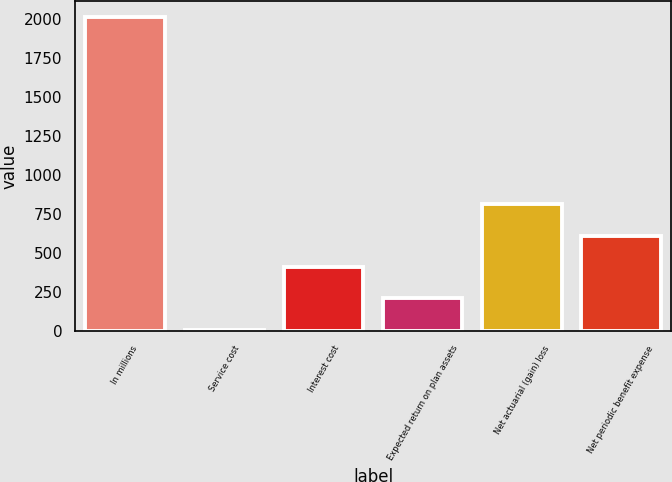Convert chart. <chart><loc_0><loc_0><loc_500><loc_500><bar_chart><fcel>In millions<fcel>Service cost<fcel>Interest cost<fcel>Expected return on plan assets<fcel>Net actuarial (gain) loss<fcel>Net periodic benefit expense<nl><fcel>2013<fcel>8.4<fcel>409.32<fcel>208.86<fcel>810.24<fcel>609.78<nl></chart> 